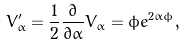Convert formula to latex. <formula><loc_0><loc_0><loc_500><loc_500>V ^ { \prime } _ { \alpha } = \frac { 1 } { 2 } \frac { \partial } { \partial \alpha } V _ { \alpha } = \phi e ^ { 2 \alpha \phi } ,</formula> 